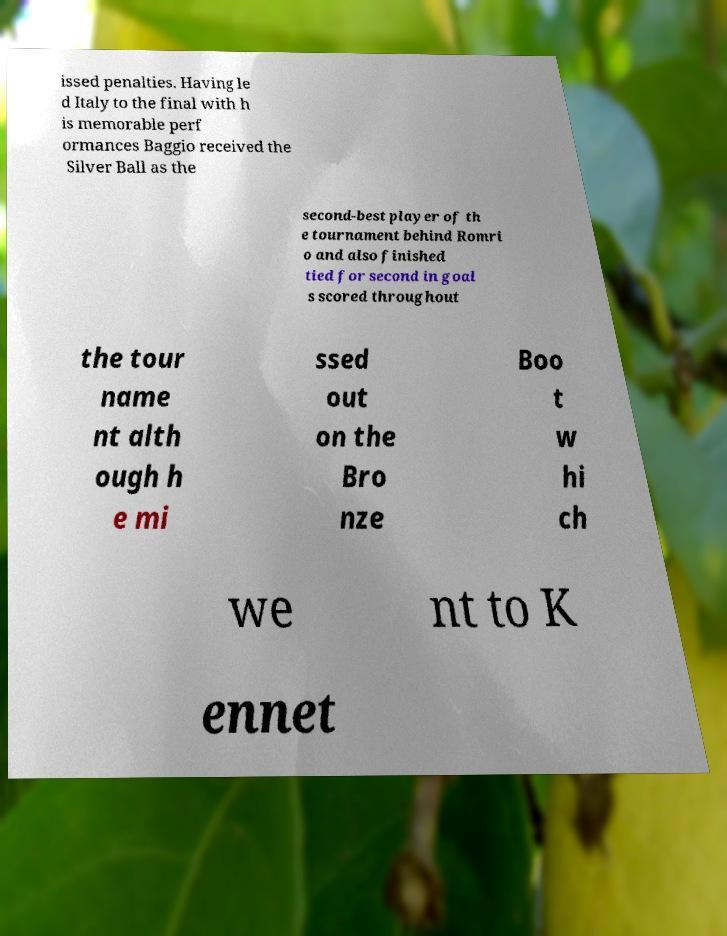There's text embedded in this image that I need extracted. Can you transcribe it verbatim? issed penalties. Having le d Italy to the final with h is memorable perf ormances Baggio received the Silver Ball as the second-best player of th e tournament behind Romri o and also finished tied for second in goal s scored throughout the tour name nt alth ough h e mi ssed out on the Bro nze Boo t w hi ch we nt to K ennet 